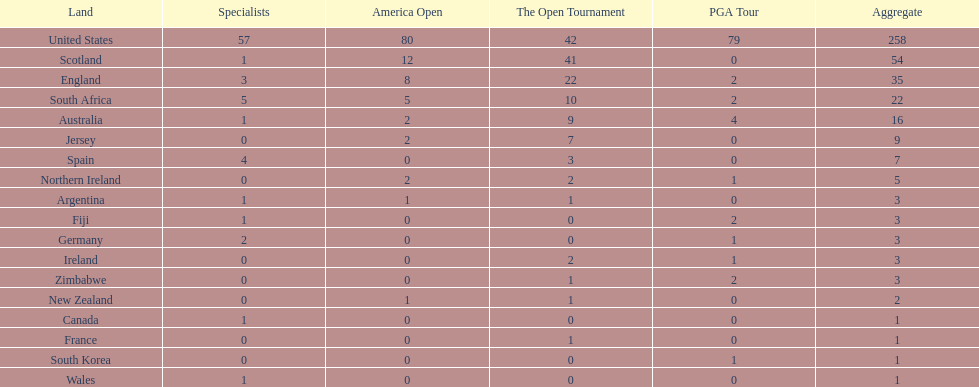Combined, how many winning golfers does england and wales have in the masters? 4. 